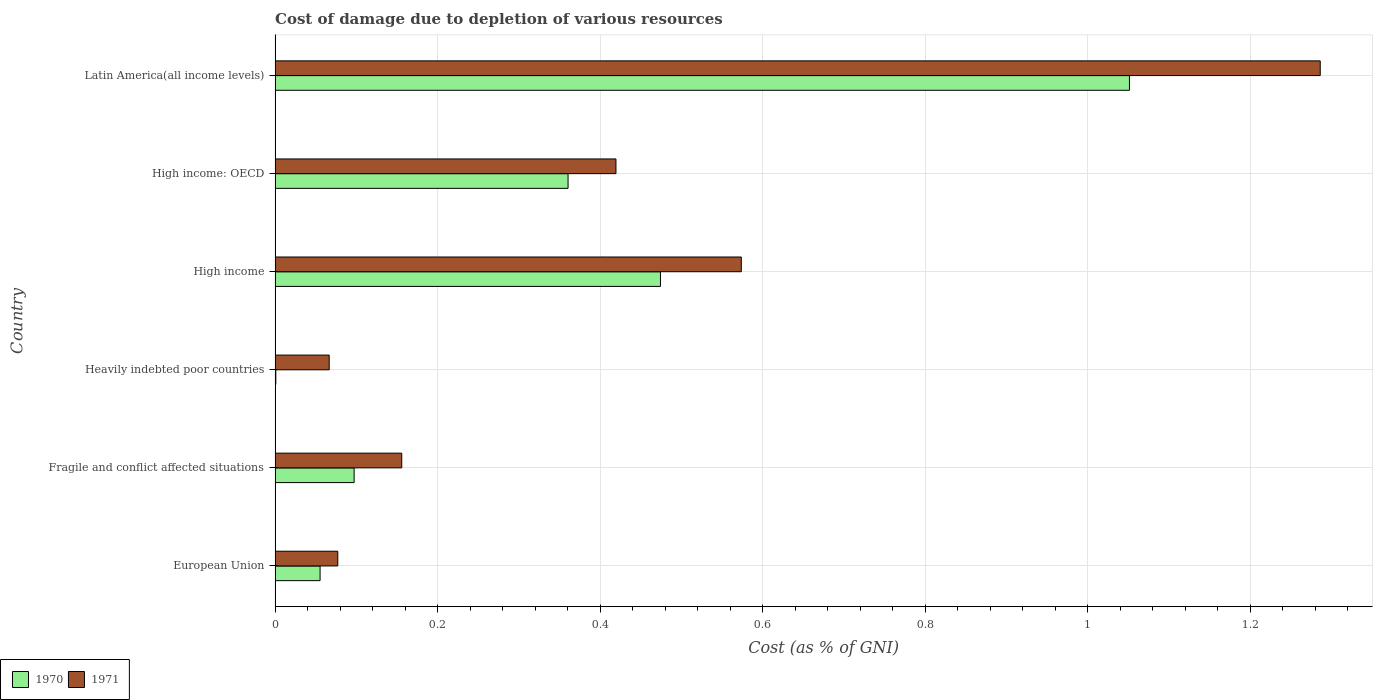How many different coloured bars are there?
Keep it short and to the point. 2. How many groups of bars are there?
Give a very brief answer. 6. Are the number of bars on each tick of the Y-axis equal?
Ensure brevity in your answer.  Yes. What is the cost of damage caused due to the depletion of various resources in 1971 in Heavily indebted poor countries?
Keep it short and to the point. 0.07. Across all countries, what is the maximum cost of damage caused due to the depletion of various resources in 1970?
Provide a short and direct response. 1.05. Across all countries, what is the minimum cost of damage caused due to the depletion of various resources in 1971?
Ensure brevity in your answer.  0.07. In which country was the cost of damage caused due to the depletion of various resources in 1970 maximum?
Make the answer very short. Latin America(all income levels). In which country was the cost of damage caused due to the depletion of various resources in 1970 minimum?
Offer a terse response. Heavily indebted poor countries. What is the total cost of damage caused due to the depletion of various resources in 1970 in the graph?
Your answer should be compact. 2.04. What is the difference between the cost of damage caused due to the depletion of various resources in 1971 in Fragile and conflict affected situations and that in High income: OECD?
Your answer should be compact. -0.26. What is the difference between the cost of damage caused due to the depletion of various resources in 1971 in European Union and the cost of damage caused due to the depletion of various resources in 1970 in Heavily indebted poor countries?
Make the answer very short. 0.08. What is the average cost of damage caused due to the depletion of various resources in 1970 per country?
Give a very brief answer. 0.34. What is the difference between the cost of damage caused due to the depletion of various resources in 1971 and cost of damage caused due to the depletion of various resources in 1970 in European Union?
Your answer should be compact. 0.02. In how many countries, is the cost of damage caused due to the depletion of various resources in 1970 greater than 1.08 %?
Your answer should be very brief. 0. What is the ratio of the cost of damage caused due to the depletion of various resources in 1970 in Fragile and conflict affected situations to that in High income?
Your answer should be compact. 0.21. Is the cost of damage caused due to the depletion of various resources in 1971 in Heavily indebted poor countries less than that in Latin America(all income levels)?
Provide a succinct answer. Yes. Is the difference between the cost of damage caused due to the depletion of various resources in 1971 in European Union and High income: OECD greater than the difference between the cost of damage caused due to the depletion of various resources in 1970 in European Union and High income: OECD?
Give a very brief answer. No. What is the difference between the highest and the second highest cost of damage caused due to the depletion of various resources in 1970?
Give a very brief answer. 0.58. What is the difference between the highest and the lowest cost of damage caused due to the depletion of various resources in 1971?
Provide a short and direct response. 1.22. In how many countries, is the cost of damage caused due to the depletion of various resources in 1970 greater than the average cost of damage caused due to the depletion of various resources in 1970 taken over all countries?
Your answer should be compact. 3. Is the sum of the cost of damage caused due to the depletion of various resources in 1971 in Fragile and conflict affected situations and High income greater than the maximum cost of damage caused due to the depletion of various resources in 1970 across all countries?
Provide a short and direct response. No. What does the 2nd bar from the top in European Union represents?
Ensure brevity in your answer.  1970. What does the 1st bar from the bottom in High income represents?
Ensure brevity in your answer.  1970. How many bars are there?
Your response must be concise. 12. How many countries are there in the graph?
Offer a terse response. 6. What is the difference between two consecutive major ticks on the X-axis?
Your answer should be very brief. 0.2. Are the values on the major ticks of X-axis written in scientific E-notation?
Ensure brevity in your answer.  No. Does the graph contain any zero values?
Offer a very short reply. No. Does the graph contain grids?
Make the answer very short. Yes. Where does the legend appear in the graph?
Keep it short and to the point. Bottom left. What is the title of the graph?
Provide a short and direct response. Cost of damage due to depletion of various resources. What is the label or title of the X-axis?
Offer a terse response. Cost (as % of GNI). What is the label or title of the Y-axis?
Offer a terse response. Country. What is the Cost (as % of GNI) in 1970 in European Union?
Provide a short and direct response. 0.06. What is the Cost (as % of GNI) of 1971 in European Union?
Offer a terse response. 0.08. What is the Cost (as % of GNI) of 1970 in Fragile and conflict affected situations?
Provide a short and direct response. 0.1. What is the Cost (as % of GNI) in 1971 in Fragile and conflict affected situations?
Your response must be concise. 0.16. What is the Cost (as % of GNI) in 1970 in Heavily indebted poor countries?
Make the answer very short. 0. What is the Cost (as % of GNI) in 1971 in Heavily indebted poor countries?
Keep it short and to the point. 0.07. What is the Cost (as % of GNI) of 1970 in High income?
Offer a very short reply. 0.47. What is the Cost (as % of GNI) in 1971 in High income?
Offer a terse response. 0.57. What is the Cost (as % of GNI) of 1970 in High income: OECD?
Give a very brief answer. 0.36. What is the Cost (as % of GNI) in 1971 in High income: OECD?
Provide a short and direct response. 0.42. What is the Cost (as % of GNI) in 1970 in Latin America(all income levels)?
Your answer should be compact. 1.05. What is the Cost (as % of GNI) of 1971 in Latin America(all income levels)?
Your answer should be compact. 1.29. Across all countries, what is the maximum Cost (as % of GNI) in 1970?
Offer a very short reply. 1.05. Across all countries, what is the maximum Cost (as % of GNI) of 1971?
Give a very brief answer. 1.29. Across all countries, what is the minimum Cost (as % of GNI) of 1970?
Your answer should be compact. 0. Across all countries, what is the minimum Cost (as % of GNI) in 1971?
Your answer should be compact. 0.07. What is the total Cost (as % of GNI) in 1970 in the graph?
Ensure brevity in your answer.  2.04. What is the total Cost (as % of GNI) in 1971 in the graph?
Offer a very short reply. 2.58. What is the difference between the Cost (as % of GNI) of 1970 in European Union and that in Fragile and conflict affected situations?
Provide a short and direct response. -0.04. What is the difference between the Cost (as % of GNI) of 1971 in European Union and that in Fragile and conflict affected situations?
Provide a short and direct response. -0.08. What is the difference between the Cost (as % of GNI) of 1970 in European Union and that in Heavily indebted poor countries?
Make the answer very short. 0.05. What is the difference between the Cost (as % of GNI) in 1971 in European Union and that in Heavily indebted poor countries?
Make the answer very short. 0.01. What is the difference between the Cost (as % of GNI) of 1970 in European Union and that in High income?
Keep it short and to the point. -0.42. What is the difference between the Cost (as % of GNI) in 1971 in European Union and that in High income?
Offer a very short reply. -0.5. What is the difference between the Cost (as % of GNI) of 1970 in European Union and that in High income: OECD?
Offer a terse response. -0.31. What is the difference between the Cost (as % of GNI) of 1971 in European Union and that in High income: OECD?
Ensure brevity in your answer.  -0.34. What is the difference between the Cost (as % of GNI) in 1970 in European Union and that in Latin America(all income levels)?
Provide a succinct answer. -1. What is the difference between the Cost (as % of GNI) in 1971 in European Union and that in Latin America(all income levels)?
Offer a terse response. -1.21. What is the difference between the Cost (as % of GNI) in 1970 in Fragile and conflict affected situations and that in Heavily indebted poor countries?
Offer a terse response. 0.1. What is the difference between the Cost (as % of GNI) in 1971 in Fragile and conflict affected situations and that in Heavily indebted poor countries?
Ensure brevity in your answer.  0.09. What is the difference between the Cost (as % of GNI) in 1970 in Fragile and conflict affected situations and that in High income?
Your answer should be compact. -0.38. What is the difference between the Cost (as % of GNI) in 1971 in Fragile and conflict affected situations and that in High income?
Offer a very short reply. -0.42. What is the difference between the Cost (as % of GNI) in 1970 in Fragile and conflict affected situations and that in High income: OECD?
Give a very brief answer. -0.26. What is the difference between the Cost (as % of GNI) of 1971 in Fragile and conflict affected situations and that in High income: OECD?
Offer a terse response. -0.26. What is the difference between the Cost (as % of GNI) of 1970 in Fragile and conflict affected situations and that in Latin America(all income levels)?
Give a very brief answer. -0.95. What is the difference between the Cost (as % of GNI) in 1971 in Fragile and conflict affected situations and that in Latin America(all income levels)?
Offer a terse response. -1.13. What is the difference between the Cost (as % of GNI) in 1970 in Heavily indebted poor countries and that in High income?
Provide a succinct answer. -0.47. What is the difference between the Cost (as % of GNI) in 1971 in Heavily indebted poor countries and that in High income?
Your answer should be compact. -0.51. What is the difference between the Cost (as % of GNI) in 1970 in Heavily indebted poor countries and that in High income: OECD?
Keep it short and to the point. -0.36. What is the difference between the Cost (as % of GNI) in 1971 in Heavily indebted poor countries and that in High income: OECD?
Provide a succinct answer. -0.35. What is the difference between the Cost (as % of GNI) in 1970 in Heavily indebted poor countries and that in Latin America(all income levels)?
Your answer should be compact. -1.05. What is the difference between the Cost (as % of GNI) of 1971 in Heavily indebted poor countries and that in Latin America(all income levels)?
Give a very brief answer. -1.22. What is the difference between the Cost (as % of GNI) of 1970 in High income and that in High income: OECD?
Keep it short and to the point. 0.11. What is the difference between the Cost (as % of GNI) in 1971 in High income and that in High income: OECD?
Provide a short and direct response. 0.15. What is the difference between the Cost (as % of GNI) in 1970 in High income and that in Latin America(all income levels)?
Your answer should be compact. -0.58. What is the difference between the Cost (as % of GNI) in 1971 in High income and that in Latin America(all income levels)?
Provide a short and direct response. -0.71. What is the difference between the Cost (as % of GNI) of 1970 in High income: OECD and that in Latin America(all income levels)?
Provide a short and direct response. -0.69. What is the difference between the Cost (as % of GNI) in 1971 in High income: OECD and that in Latin America(all income levels)?
Keep it short and to the point. -0.87. What is the difference between the Cost (as % of GNI) in 1970 in European Union and the Cost (as % of GNI) in 1971 in Fragile and conflict affected situations?
Give a very brief answer. -0.1. What is the difference between the Cost (as % of GNI) of 1970 in European Union and the Cost (as % of GNI) of 1971 in Heavily indebted poor countries?
Provide a succinct answer. -0.01. What is the difference between the Cost (as % of GNI) of 1970 in European Union and the Cost (as % of GNI) of 1971 in High income?
Your answer should be very brief. -0.52. What is the difference between the Cost (as % of GNI) in 1970 in European Union and the Cost (as % of GNI) in 1971 in High income: OECD?
Your answer should be very brief. -0.36. What is the difference between the Cost (as % of GNI) of 1970 in European Union and the Cost (as % of GNI) of 1971 in Latin America(all income levels)?
Ensure brevity in your answer.  -1.23. What is the difference between the Cost (as % of GNI) in 1970 in Fragile and conflict affected situations and the Cost (as % of GNI) in 1971 in Heavily indebted poor countries?
Give a very brief answer. 0.03. What is the difference between the Cost (as % of GNI) in 1970 in Fragile and conflict affected situations and the Cost (as % of GNI) in 1971 in High income?
Your answer should be compact. -0.48. What is the difference between the Cost (as % of GNI) of 1970 in Fragile and conflict affected situations and the Cost (as % of GNI) of 1971 in High income: OECD?
Provide a short and direct response. -0.32. What is the difference between the Cost (as % of GNI) in 1970 in Fragile and conflict affected situations and the Cost (as % of GNI) in 1971 in Latin America(all income levels)?
Provide a succinct answer. -1.19. What is the difference between the Cost (as % of GNI) of 1970 in Heavily indebted poor countries and the Cost (as % of GNI) of 1971 in High income?
Provide a succinct answer. -0.57. What is the difference between the Cost (as % of GNI) in 1970 in Heavily indebted poor countries and the Cost (as % of GNI) in 1971 in High income: OECD?
Offer a terse response. -0.42. What is the difference between the Cost (as % of GNI) in 1970 in Heavily indebted poor countries and the Cost (as % of GNI) in 1971 in Latin America(all income levels)?
Provide a short and direct response. -1.29. What is the difference between the Cost (as % of GNI) of 1970 in High income and the Cost (as % of GNI) of 1971 in High income: OECD?
Provide a succinct answer. 0.05. What is the difference between the Cost (as % of GNI) of 1970 in High income and the Cost (as % of GNI) of 1971 in Latin America(all income levels)?
Offer a terse response. -0.81. What is the difference between the Cost (as % of GNI) of 1970 in High income: OECD and the Cost (as % of GNI) of 1971 in Latin America(all income levels)?
Offer a terse response. -0.93. What is the average Cost (as % of GNI) of 1970 per country?
Your answer should be very brief. 0.34. What is the average Cost (as % of GNI) in 1971 per country?
Your answer should be compact. 0.43. What is the difference between the Cost (as % of GNI) of 1970 and Cost (as % of GNI) of 1971 in European Union?
Provide a short and direct response. -0.02. What is the difference between the Cost (as % of GNI) of 1970 and Cost (as % of GNI) of 1971 in Fragile and conflict affected situations?
Provide a short and direct response. -0.06. What is the difference between the Cost (as % of GNI) in 1970 and Cost (as % of GNI) in 1971 in Heavily indebted poor countries?
Ensure brevity in your answer.  -0.07. What is the difference between the Cost (as % of GNI) in 1970 and Cost (as % of GNI) in 1971 in High income?
Provide a succinct answer. -0.1. What is the difference between the Cost (as % of GNI) of 1970 and Cost (as % of GNI) of 1971 in High income: OECD?
Ensure brevity in your answer.  -0.06. What is the difference between the Cost (as % of GNI) in 1970 and Cost (as % of GNI) in 1971 in Latin America(all income levels)?
Make the answer very short. -0.23. What is the ratio of the Cost (as % of GNI) in 1970 in European Union to that in Fragile and conflict affected situations?
Make the answer very short. 0.57. What is the ratio of the Cost (as % of GNI) in 1971 in European Union to that in Fragile and conflict affected situations?
Keep it short and to the point. 0.49. What is the ratio of the Cost (as % of GNI) in 1970 in European Union to that in Heavily indebted poor countries?
Give a very brief answer. 61.27. What is the ratio of the Cost (as % of GNI) in 1971 in European Union to that in Heavily indebted poor countries?
Your answer should be compact. 1.16. What is the ratio of the Cost (as % of GNI) in 1970 in European Union to that in High income?
Your response must be concise. 0.12. What is the ratio of the Cost (as % of GNI) of 1971 in European Union to that in High income?
Keep it short and to the point. 0.13. What is the ratio of the Cost (as % of GNI) in 1970 in European Union to that in High income: OECD?
Ensure brevity in your answer.  0.15. What is the ratio of the Cost (as % of GNI) of 1971 in European Union to that in High income: OECD?
Ensure brevity in your answer.  0.18. What is the ratio of the Cost (as % of GNI) of 1970 in European Union to that in Latin America(all income levels)?
Give a very brief answer. 0.05. What is the ratio of the Cost (as % of GNI) in 1970 in Fragile and conflict affected situations to that in Heavily indebted poor countries?
Provide a short and direct response. 107.61. What is the ratio of the Cost (as % of GNI) of 1971 in Fragile and conflict affected situations to that in Heavily indebted poor countries?
Offer a very short reply. 2.34. What is the ratio of the Cost (as % of GNI) of 1970 in Fragile and conflict affected situations to that in High income?
Keep it short and to the point. 0.21. What is the ratio of the Cost (as % of GNI) of 1971 in Fragile and conflict affected situations to that in High income?
Your response must be concise. 0.27. What is the ratio of the Cost (as % of GNI) of 1970 in Fragile and conflict affected situations to that in High income: OECD?
Provide a succinct answer. 0.27. What is the ratio of the Cost (as % of GNI) of 1971 in Fragile and conflict affected situations to that in High income: OECD?
Your answer should be compact. 0.37. What is the ratio of the Cost (as % of GNI) of 1970 in Fragile and conflict affected situations to that in Latin America(all income levels)?
Keep it short and to the point. 0.09. What is the ratio of the Cost (as % of GNI) of 1971 in Fragile and conflict affected situations to that in Latin America(all income levels)?
Provide a succinct answer. 0.12. What is the ratio of the Cost (as % of GNI) in 1970 in Heavily indebted poor countries to that in High income?
Keep it short and to the point. 0. What is the ratio of the Cost (as % of GNI) of 1971 in Heavily indebted poor countries to that in High income?
Give a very brief answer. 0.12. What is the ratio of the Cost (as % of GNI) of 1970 in Heavily indebted poor countries to that in High income: OECD?
Give a very brief answer. 0. What is the ratio of the Cost (as % of GNI) in 1971 in Heavily indebted poor countries to that in High income: OECD?
Give a very brief answer. 0.16. What is the ratio of the Cost (as % of GNI) in 1970 in Heavily indebted poor countries to that in Latin America(all income levels)?
Offer a very short reply. 0. What is the ratio of the Cost (as % of GNI) in 1971 in Heavily indebted poor countries to that in Latin America(all income levels)?
Offer a terse response. 0.05. What is the ratio of the Cost (as % of GNI) of 1970 in High income to that in High income: OECD?
Your response must be concise. 1.32. What is the ratio of the Cost (as % of GNI) of 1971 in High income to that in High income: OECD?
Ensure brevity in your answer.  1.37. What is the ratio of the Cost (as % of GNI) in 1970 in High income to that in Latin America(all income levels)?
Your response must be concise. 0.45. What is the ratio of the Cost (as % of GNI) of 1971 in High income to that in Latin America(all income levels)?
Your answer should be very brief. 0.45. What is the ratio of the Cost (as % of GNI) of 1970 in High income: OECD to that in Latin America(all income levels)?
Offer a very short reply. 0.34. What is the ratio of the Cost (as % of GNI) in 1971 in High income: OECD to that in Latin America(all income levels)?
Make the answer very short. 0.33. What is the difference between the highest and the second highest Cost (as % of GNI) in 1970?
Offer a terse response. 0.58. What is the difference between the highest and the second highest Cost (as % of GNI) of 1971?
Give a very brief answer. 0.71. What is the difference between the highest and the lowest Cost (as % of GNI) of 1970?
Provide a succinct answer. 1.05. What is the difference between the highest and the lowest Cost (as % of GNI) in 1971?
Offer a very short reply. 1.22. 